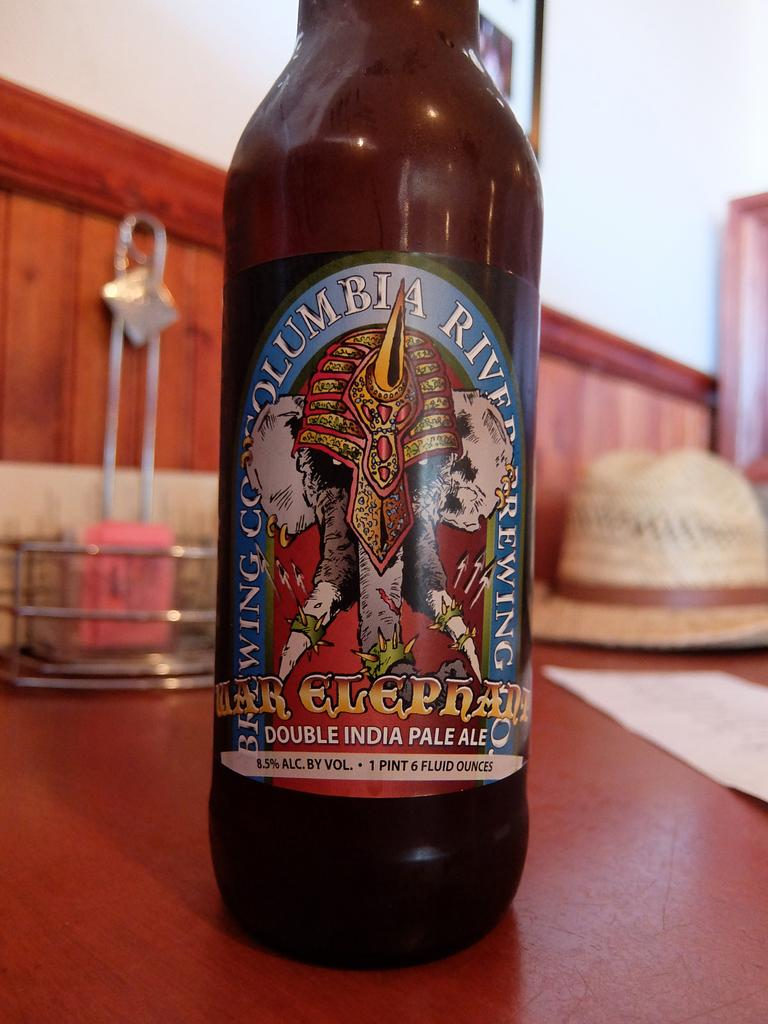What object can be seen in the image? There is a bottle in the image. What type of sea creature is swimming near the bottle in the image? There is no sea creature present in the image; it only contains a bottle. What topics are being discussed by the people in the image? There are no people present in the image, so there is no discussion taking place. 